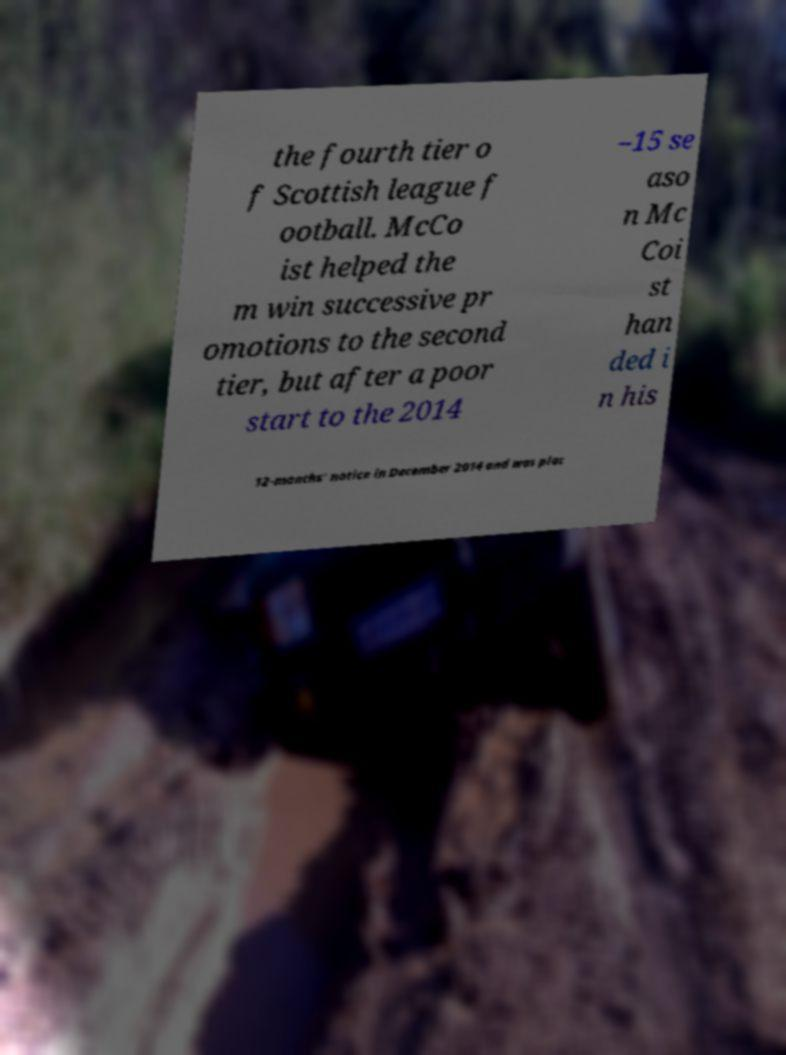What messages or text are displayed in this image? I need them in a readable, typed format. the fourth tier o f Scottish league f ootball. McCo ist helped the m win successive pr omotions to the second tier, but after a poor start to the 2014 –15 se aso n Mc Coi st han ded i n his 12-months' notice in December 2014 and was plac 